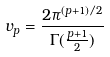Convert formula to latex. <formula><loc_0><loc_0><loc_500><loc_500>v _ { p } = \frac { 2 \pi ^ { ( p + 1 ) / 2 } } { \Gamma ( \frac { p + 1 } { 2 } ) }</formula> 